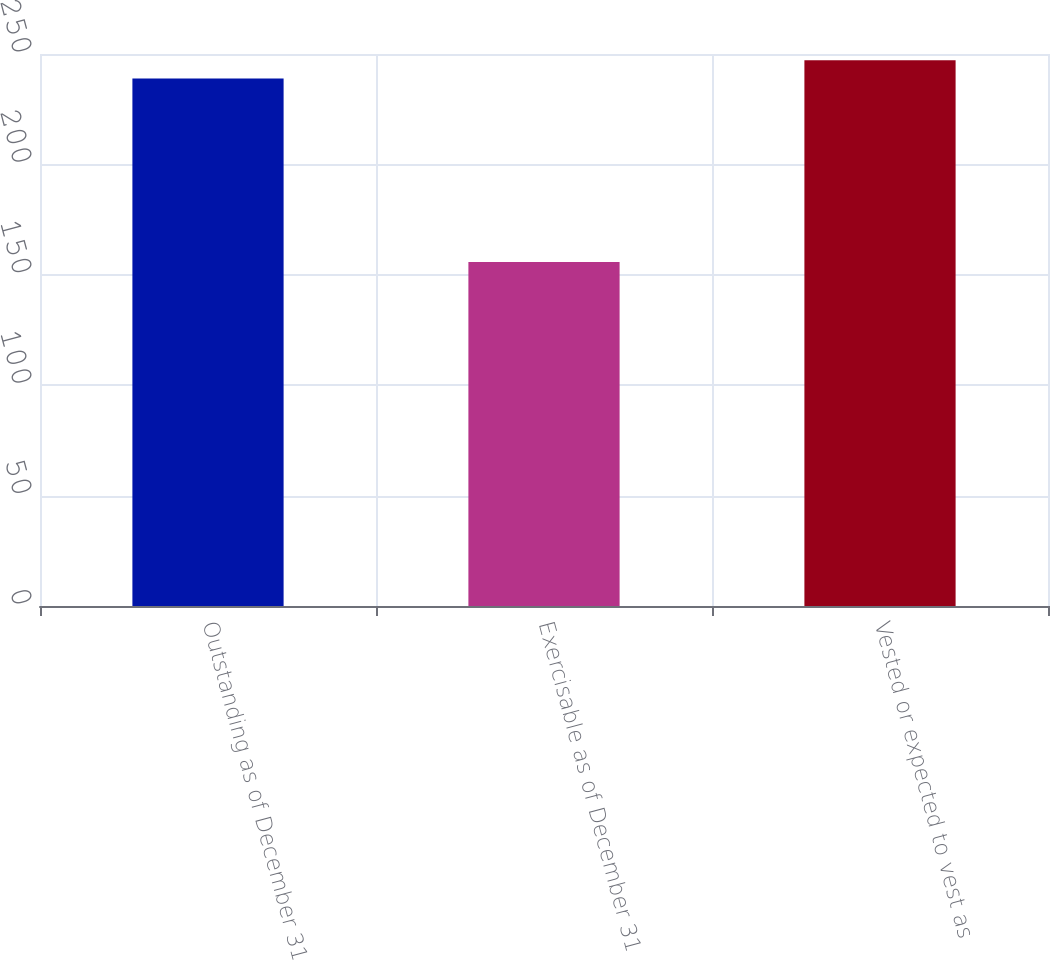<chart> <loc_0><loc_0><loc_500><loc_500><bar_chart><fcel>Outstanding as of December 31<fcel>Exercisable as of December 31<fcel>Vested or expected to vest as<nl><fcel>238.9<fcel>155.8<fcel>247.21<nl></chart> 